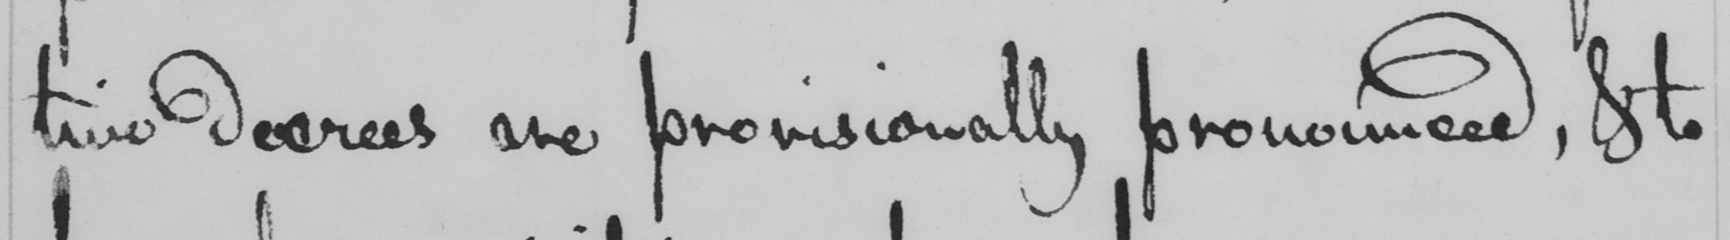What text is written in this handwritten line? tive decrees are provisionally pronounced , & to 